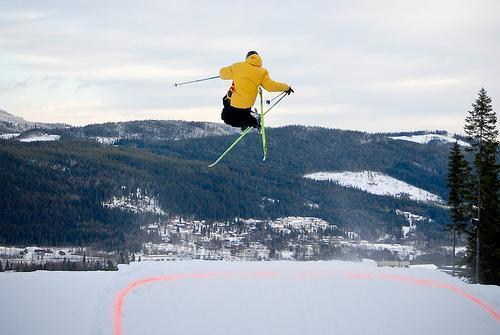How many people are pictured?
Give a very brief answer. 1. How many skis do you see?
Give a very brief answer. 2. 